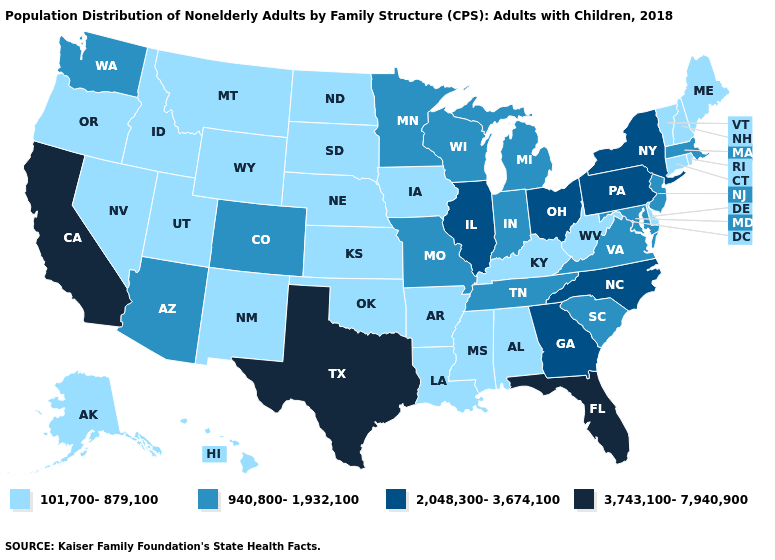What is the value of Minnesota?
Answer briefly. 940,800-1,932,100. Does California have the highest value in the West?
Keep it brief. Yes. Name the states that have a value in the range 2,048,300-3,674,100?
Keep it brief. Georgia, Illinois, New York, North Carolina, Ohio, Pennsylvania. Does the map have missing data?
Quick response, please. No. What is the value of Kentucky?
Be succinct. 101,700-879,100. What is the value of Maryland?
Keep it brief. 940,800-1,932,100. Among the states that border North Carolina , does Georgia have the lowest value?
Short answer required. No. Does the map have missing data?
Be succinct. No. What is the value of Delaware?
Concise answer only. 101,700-879,100. Name the states that have a value in the range 2,048,300-3,674,100?
Short answer required. Georgia, Illinois, New York, North Carolina, Ohio, Pennsylvania. What is the highest value in the MidWest ?
Keep it brief. 2,048,300-3,674,100. What is the lowest value in the South?
Give a very brief answer. 101,700-879,100. What is the lowest value in the West?
Answer briefly. 101,700-879,100. What is the value of Vermont?
Write a very short answer. 101,700-879,100. Name the states that have a value in the range 940,800-1,932,100?
Keep it brief. Arizona, Colorado, Indiana, Maryland, Massachusetts, Michigan, Minnesota, Missouri, New Jersey, South Carolina, Tennessee, Virginia, Washington, Wisconsin. 